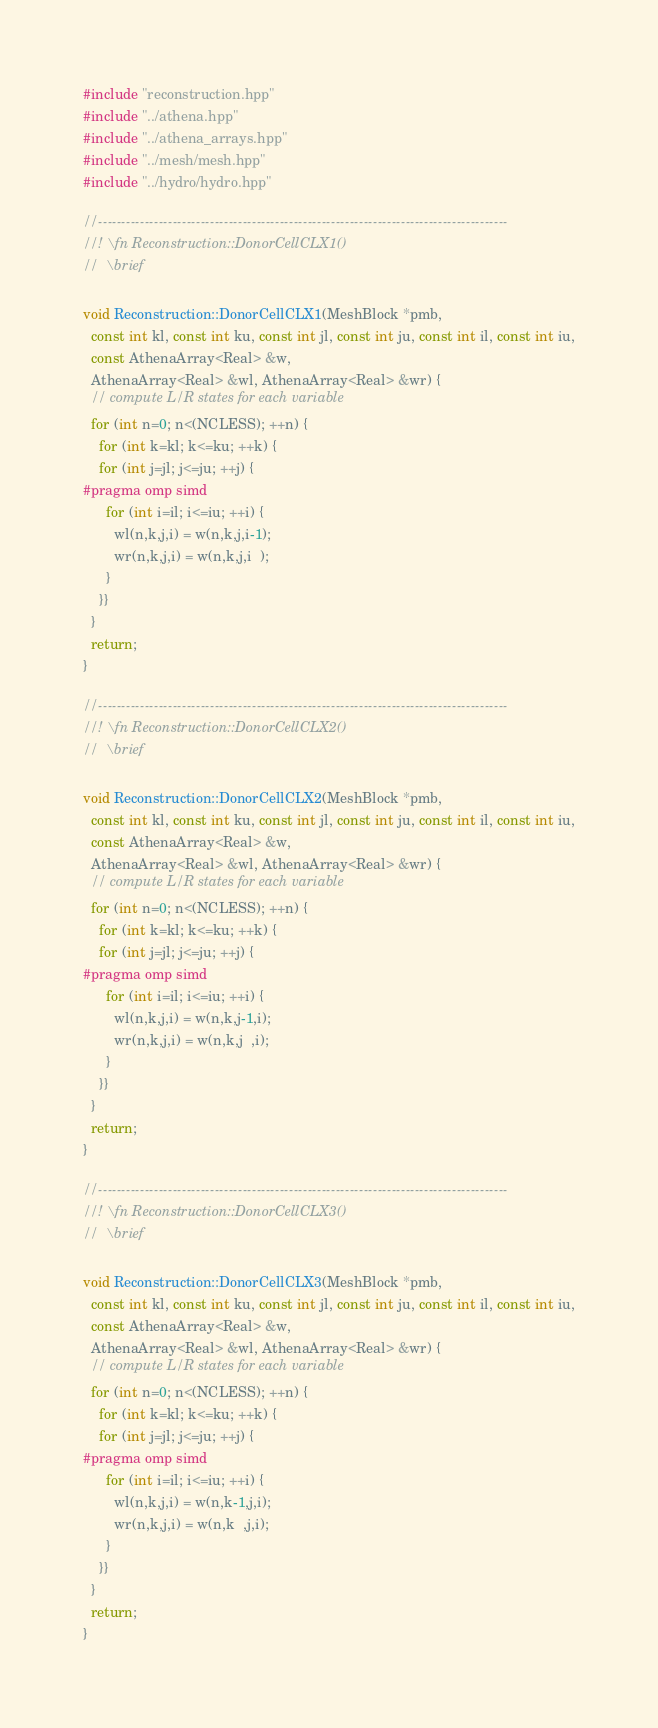Convert code to text. <code><loc_0><loc_0><loc_500><loc_500><_C++_>#include "reconstruction.hpp"
#include "../athena.hpp"
#include "../athena_arrays.hpp"
#include "../mesh/mesh.hpp"
#include "../hydro/hydro.hpp"

//----------------------------------------------------------------------------------------
//! \fn Reconstruction::DonorCellCLX1()
//  \brief

void Reconstruction::DonorCellCLX1(MeshBlock *pmb,
  const int kl, const int ku, const int jl, const int ju, const int il, const int iu,
  const AthenaArray<Real> &w,
  AthenaArray<Real> &wl, AthenaArray<Real> &wr) {
  // compute L/R states for each variable
  for (int n=0; n<(NCLESS); ++n) {
    for (int k=kl; k<=ku; ++k) {
    for (int j=jl; j<=ju; ++j) {
#pragma omp simd
      for (int i=il; i<=iu; ++i) {
        wl(n,k,j,i) = w(n,k,j,i-1);
        wr(n,k,j,i) = w(n,k,j,i  );
      }
    }}
  }
  return;
}

//----------------------------------------------------------------------------------------
//! \fn Reconstruction::DonorCellCLX2()
//  \brief

void Reconstruction::DonorCellCLX2(MeshBlock *pmb,
  const int kl, const int ku, const int jl, const int ju, const int il, const int iu,
  const AthenaArray<Real> &w,
  AthenaArray<Real> &wl, AthenaArray<Real> &wr) {
  // compute L/R states for each variable
  for (int n=0; n<(NCLESS); ++n) {
    for (int k=kl; k<=ku; ++k) {
    for (int j=jl; j<=ju; ++j) {
#pragma omp simd
      for (int i=il; i<=iu; ++i) {
        wl(n,k,j,i) = w(n,k,j-1,i);
        wr(n,k,j,i) = w(n,k,j  ,i);
      }
    }}
  }
  return;
}

//----------------------------------------------------------------------------------------
//! \fn Reconstruction::DonorCellCLX3()
//  \brief

void Reconstruction::DonorCellCLX3(MeshBlock *pmb,
  const int kl, const int ku, const int jl, const int ju, const int il, const int iu,
  const AthenaArray<Real> &w,
  AthenaArray<Real> &wl, AthenaArray<Real> &wr) {
  // compute L/R states for each variable
  for (int n=0; n<(NCLESS); ++n) {
    for (int k=kl; k<=ku; ++k) {
    for (int j=jl; j<=ju; ++j) {
#pragma omp simd
      for (int i=il; i<=iu; ++i) {
        wl(n,k,j,i) = w(n,k-1,j,i);
        wr(n,k,j,i) = w(n,k  ,j,i);
      }
    }}
  }
  return;
}
</code> 